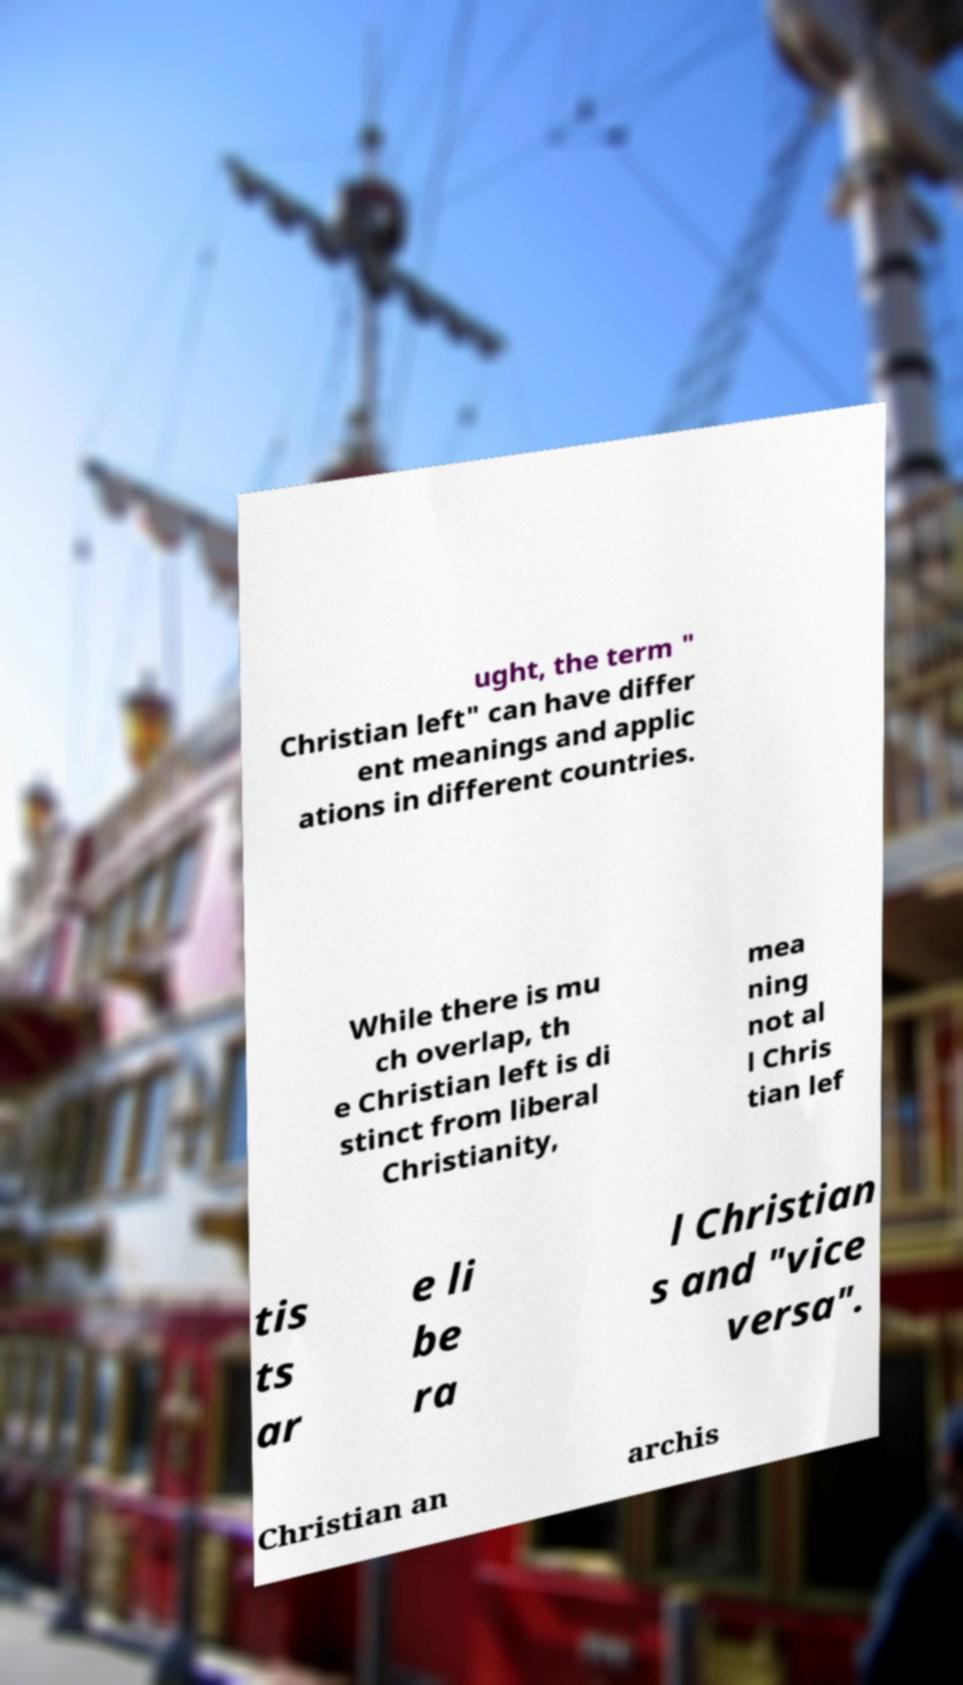There's text embedded in this image that I need extracted. Can you transcribe it verbatim? ught, the term " Christian left" can have differ ent meanings and applic ations in different countries. While there is mu ch overlap, th e Christian left is di stinct from liberal Christianity, mea ning not al l Chris tian lef tis ts ar e li be ra l Christian s and "vice versa". Christian an archis 